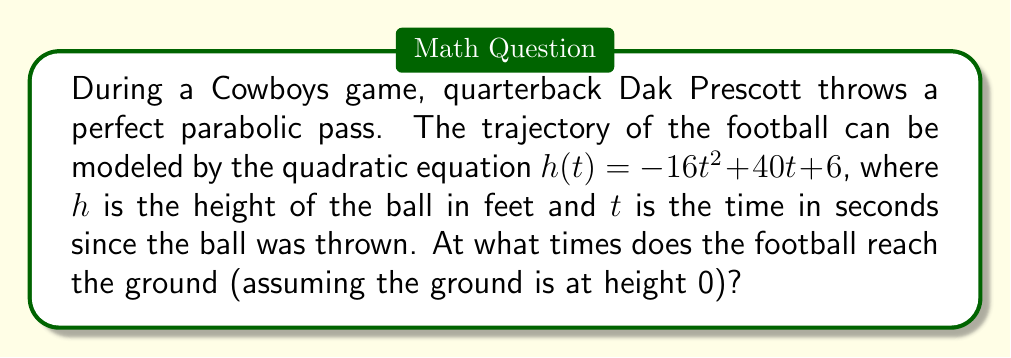Show me your answer to this math problem. To find when the football reaches the ground, we need to solve the equation $h(t) = 0$. This means we need to find the roots of the quadratic equation:

$$-16t^2 + 40t + 6 = 0$$

We can solve this using the quadratic formula: $t = \frac{-b \pm \sqrt{b^2 - 4ac}}{2a}$

Where $a = -16$, $b = 40$, and $c = 6$

Step 1: Calculate the discriminant
$$b^2 - 4ac = 40^2 - 4(-16)(6) = 1600 + 384 = 1984$$

Step 2: Apply the quadratic formula
$$t = \frac{-40 \pm \sqrt{1984}}{2(-16)}$$

Step 3: Simplify
$$t = \frac{-40 \pm 44.54}{-32}$$

Step 4: Calculate the two solutions
$$t_1 = \frac{-40 + 44.54}{-32} = \frac{4.54}{-32} = -0.14$$
$$t_2 = \frac{-40 - 44.54}{-32} = \frac{-84.54}{-32} = 2.64$$

Since time cannot be negative in this context, we discard the negative solution.
Answer: The football reaches the ground approximately 2.64 seconds after it is thrown. 